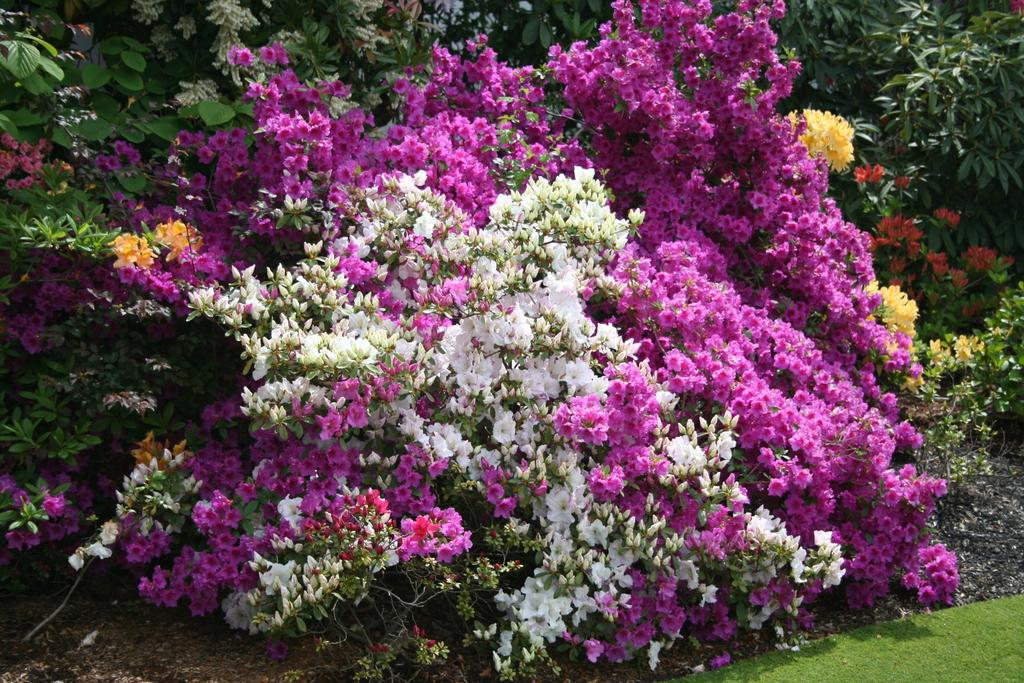What type of vegetation can be seen in the image? There are flowers and leaves in the image. What else can be seen in the image besides flowers and leaves? There are plants in the image. What is the tendency of the zoo in the image? There is no zoo present in the image, so it is not possible to determine any tendencies. 